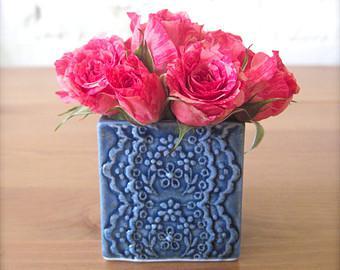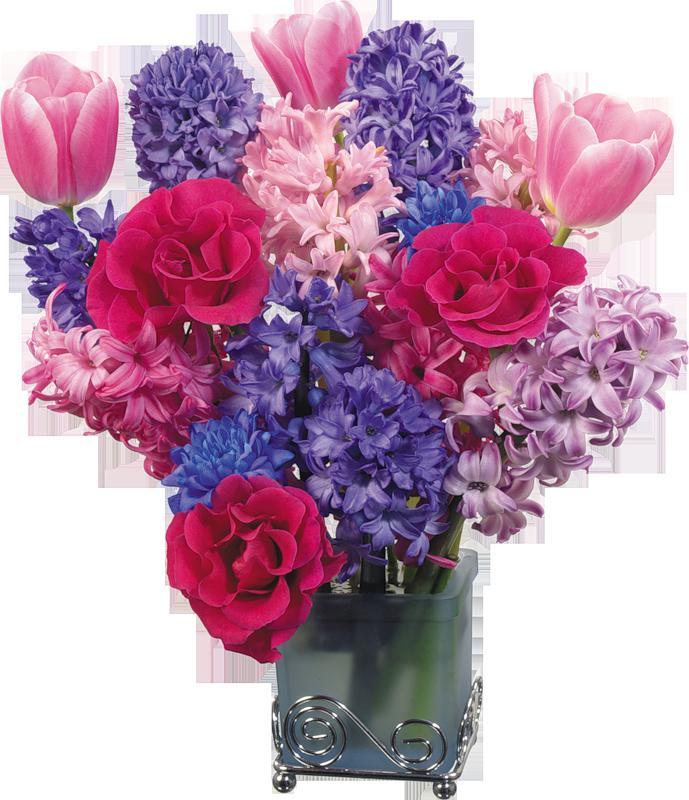The first image is the image on the left, the second image is the image on the right. Assess this claim about the two images: "The vase on the left contains all pink flowers, while the vase on the right contains at least some purple flowers.". Correct or not? Answer yes or no. Yes. The first image is the image on the left, the second image is the image on the right. Assess this claim about the two images: "The left image features a square vase displayed head-on that holds only dark pink roses.". Correct or not? Answer yes or no. Yes. 